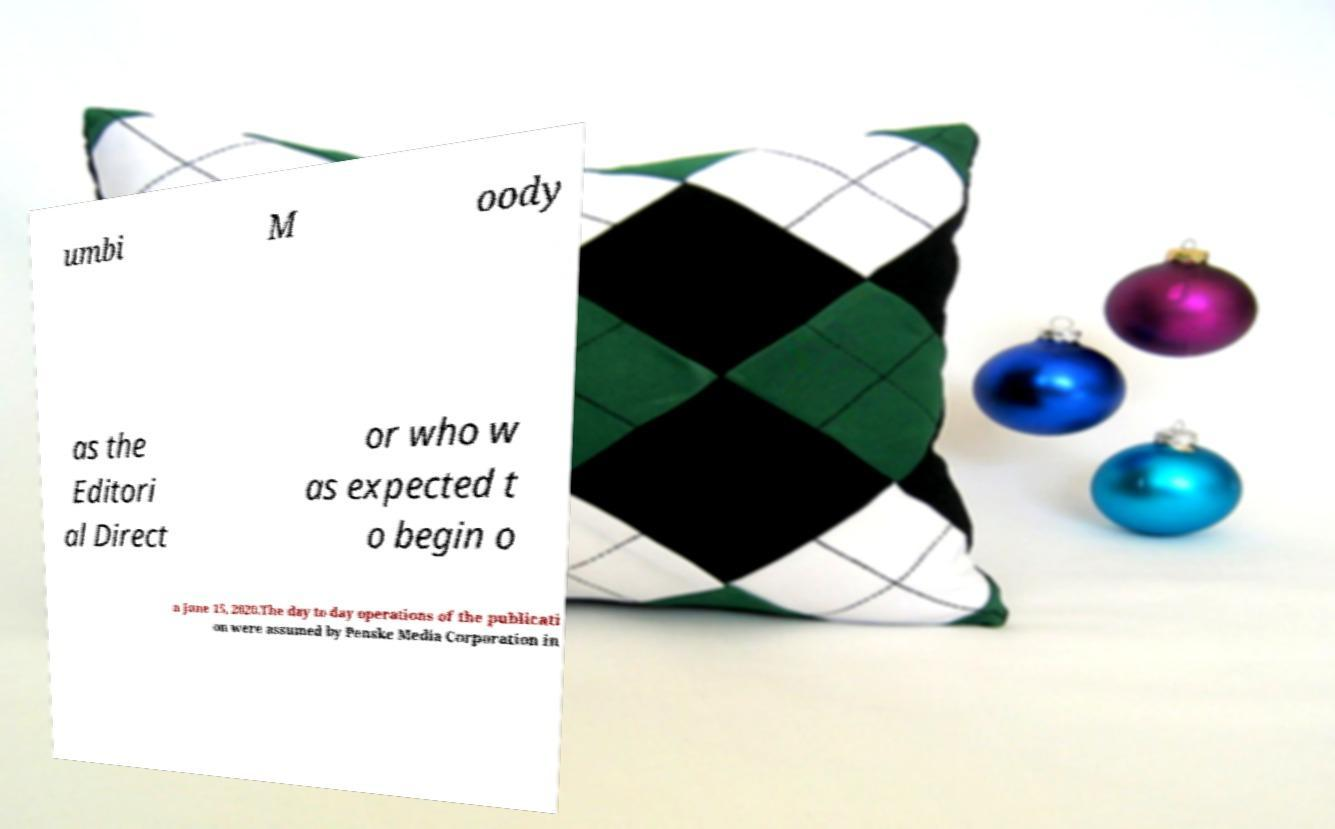Please read and relay the text visible in this image. What does it say? umbi M oody as the Editori al Direct or who w as expected t o begin o n June 15, 2020.The day to day operations of the publicati on were assumed by Penske Media Corporation in 